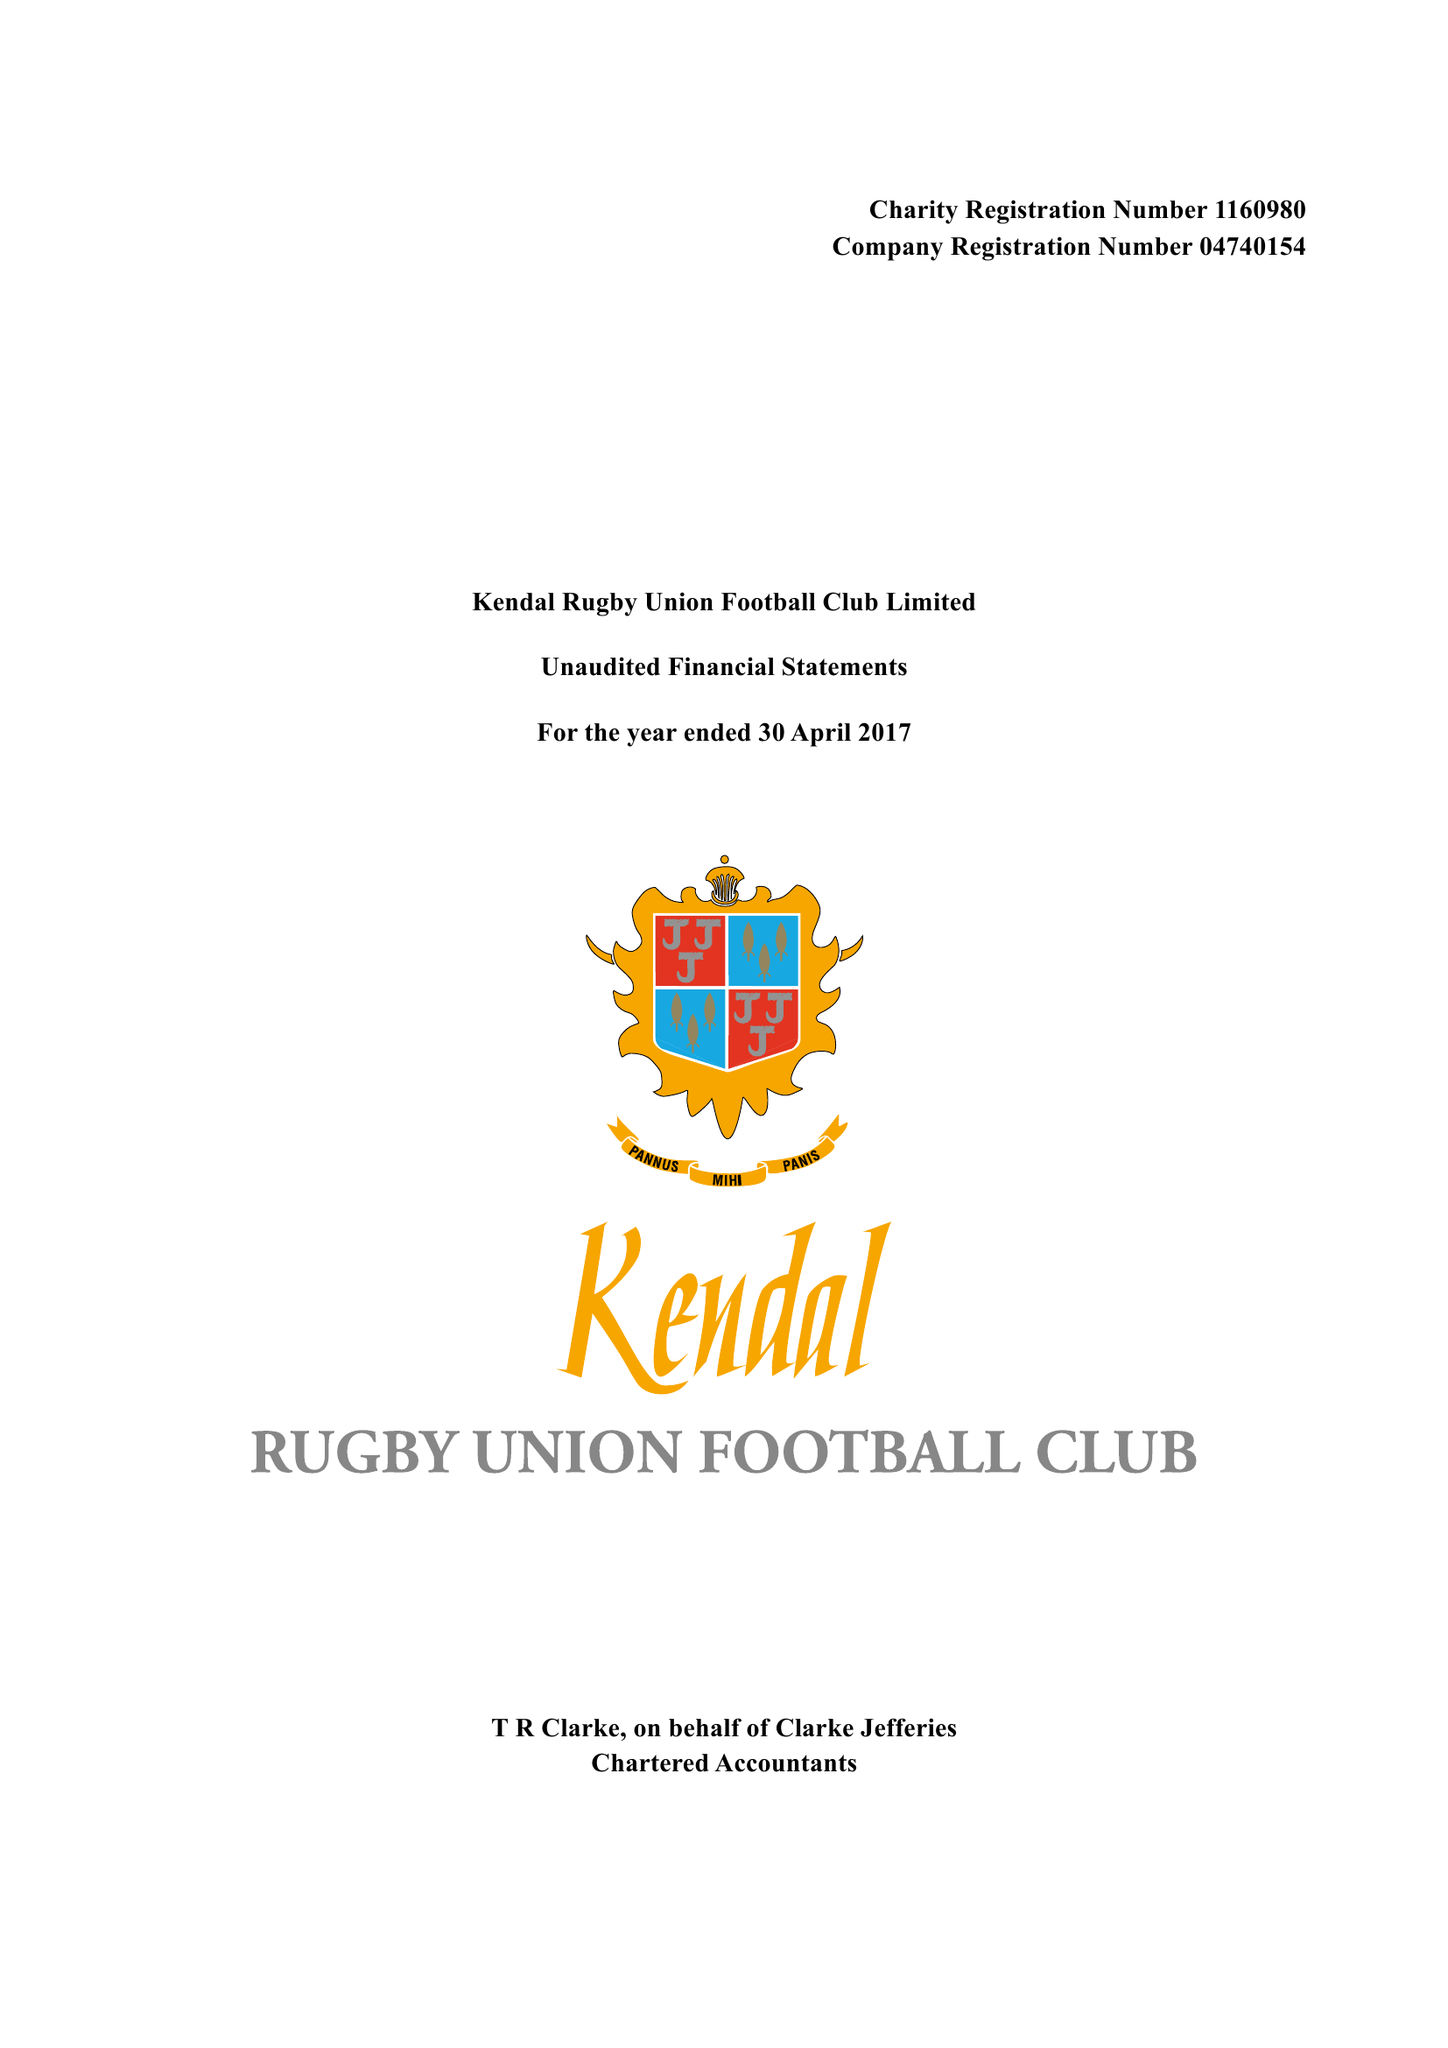What is the value for the spending_annually_in_british_pounds?
Answer the question using a single word or phrase. 112508.00 